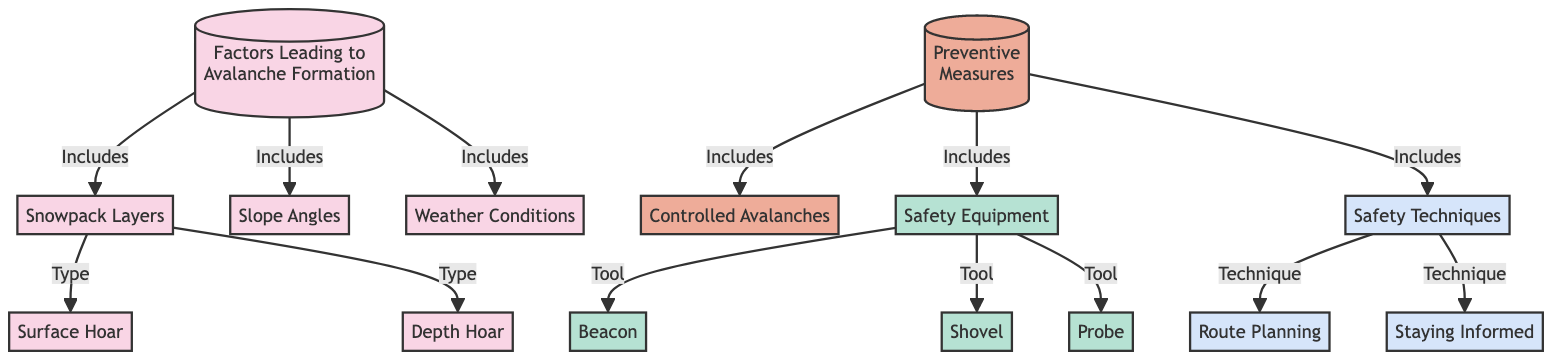What factors lead to avalanche formation? The diagram specifies that the factors leading to avalanche formation include snowpack layers, slope angles, weather conditions, surface hoar, and depth hoar.
Answer: Snowpack Layers, Slope Angles, Weather Conditions, Surface Hoar, Depth Hoar How many types of snowpack layers are mentioned? The diagram highlights two types of snowpack layers: surface hoar and depth hoar, indicating they are both classified under snowpack layers.
Answer: 2 What preventive measure involves triggering avalanches? The diagram mentions controlled avalanches as a preventive measure utilized to manage avalanche risks effectively by intentionally triggering an avalanche in a controlled setting.
Answer: Controlled Avalanches Which equipment is categorized as safety equipment? Safety equipment includes beacon, shovel, and probe as indicated in the diagram. Thus, any of these can be accepted as answers.
Answer: Beacon, Shovel, Probe What technique is necessary for effective route planning? The diagram includes route planning as a safety technique under the category of preventive measures, emphasizing its importance in ensuring safety while navigating in avalanche-prone areas.
Answer: Route Planning How are weather conditions connected to avalanche formation? Weather conditions are explicitly labeled as a factor leading to avalanche formation in the diagram, showcasing that they play a significant role in determining the likelihood of an avalanche occurring.
Answer: Included What is the relationship between safety techniques and staying informed? The diagram indicates both safety techniques and staying informed as part of preventive measures, suggesting that staying informed is a key safety technique crucial for avoiding risks associated with avalanches.
Answer: Technique What nodes branch out from the "Factors Leading to Avalanche Formation"? The factors leading to avalanche formation branch out to snowpack layers, slope angles, and weather conditions, showcasing these as essential components contributing to avalanche formation.
Answer: Snowpack Layers, Slope Angles, Weather Conditions Which tool is not considered safety equipment in the diagram? While the diagram includes a beacon, shovel, and probe under safety equipment, any other tool not listed would be deemed as not considered safety equipment in the context of avalanche safety.
Answer: Any tool not listed 